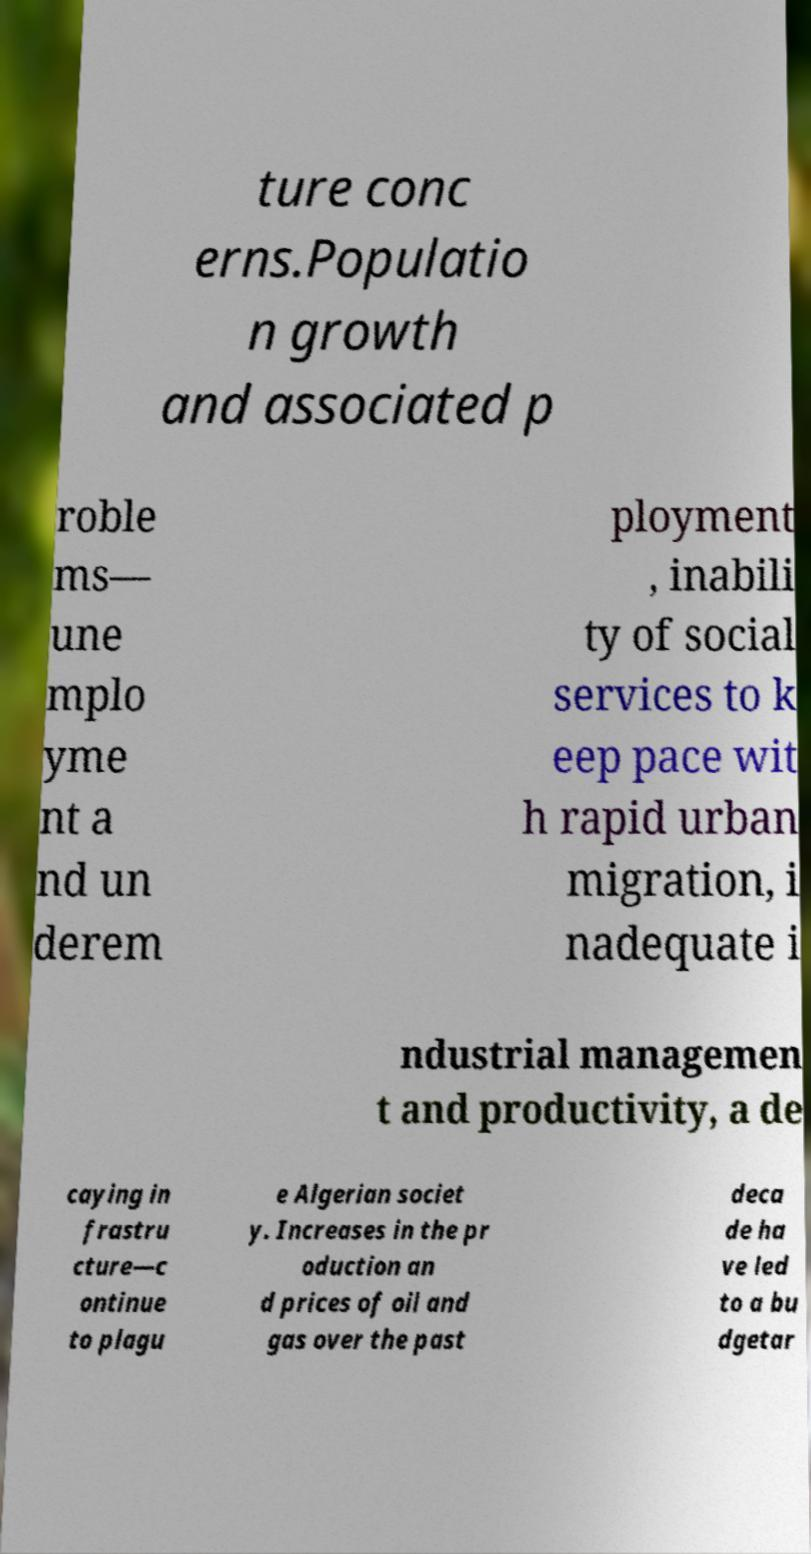Can you accurately transcribe the text from the provided image for me? ture conc erns.Populatio n growth and associated p roble ms— une mplo yme nt a nd un derem ployment , inabili ty of social services to k eep pace wit h rapid urban migration, i nadequate i ndustrial managemen t and productivity, a de caying in frastru cture—c ontinue to plagu e Algerian societ y. Increases in the pr oduction an d prices of oil and gas over the past deca de ha ve led to a bu dgetar 